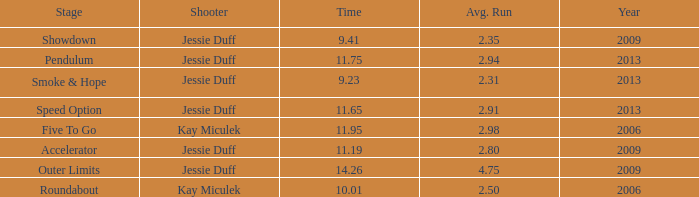What is the total amount of time for years prior to 2013 when speed option is the stage? None. 